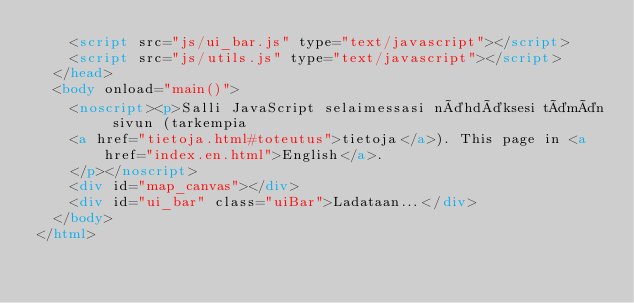Convert code to text. <code><loc_0><loc_0><loc_500><loc_500><_HTML_>    <script src="js/ui_bar.js" type="text/javascript"></script>
    <script src="js/utils.js" type="text/javascript"></script>
  </head>
  <body onload="main()">
    <noscript><p>Salli JavaScript selaimessasi nähdäksesi tämän sivun (tarkempia
    <a href="tietoja.html#toteutus">tietoja</a>). This page in <a href="index.en.html">English</a>.
    </p></noscript>
    <div id="map_canvas"></div>
    <div id="ui_bar" class="uiBar">Ladataan...</div>
  </body>
</html>
</code> 